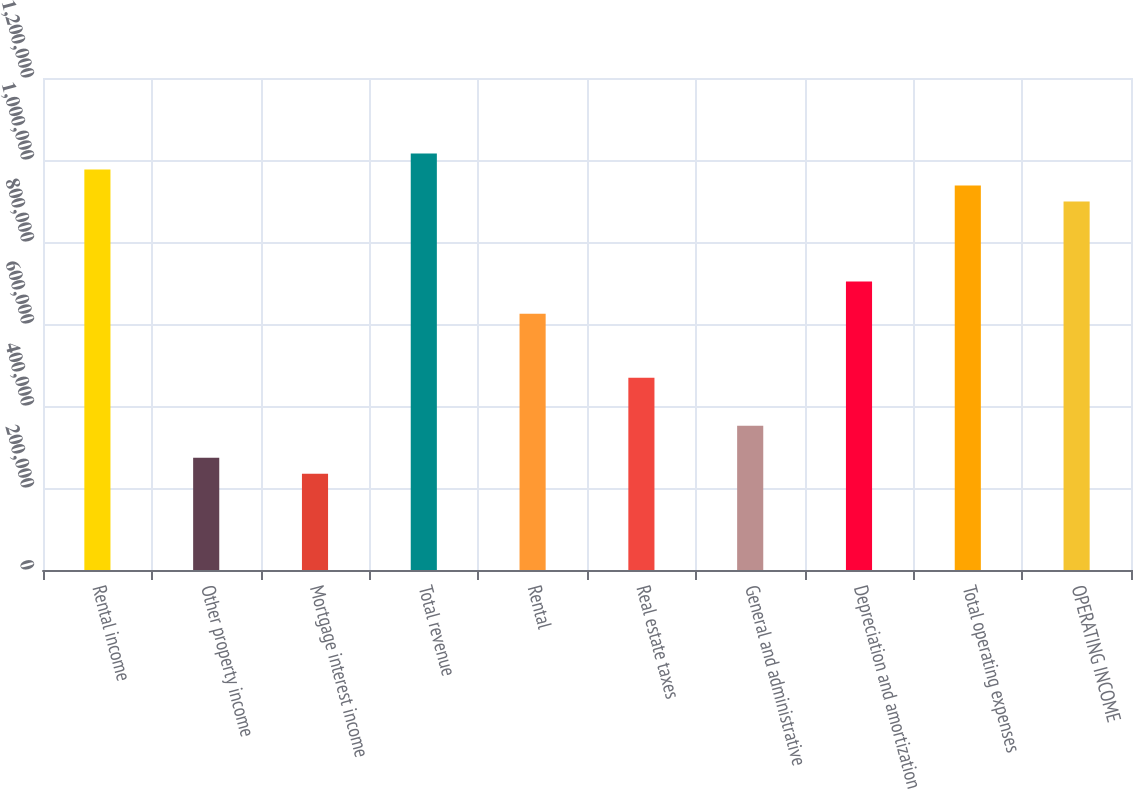Convert chart to OTSL. <chart><loc_0><loc_0><loc_500><loc_500><bar_chart><fcel>Rental income<fcel>Other property income<fcel>Mortgage interest income<fcel>Total revenue<fcel>Rental<fcel>Real estate taxes<fcel>General and administrative<fcel>Depreciation and amortization<fcel>Total operating expenses<fcel>OPERATING INCOME<nl><fcel>977019<fcel>273566<fcel>234485<fcel>1.0161e+06<fcel>625292<fcel>468969<fcel>351727<fcel>703454<fcel>937938<fcel>898858<nl></chart> 